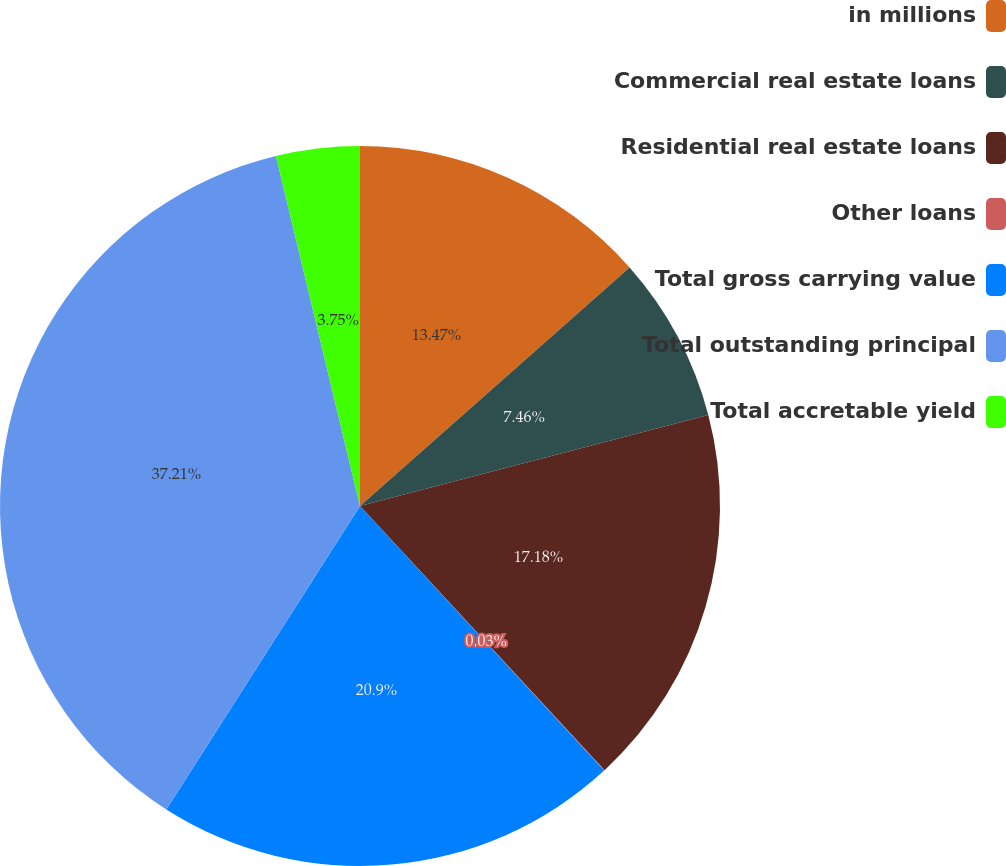Convert chart to OTSL. <chart><loc_0><loc_0><loc_500><loc_500><pie_chart><fcel>in millions<fcel>Commercial real estate loans<fcel>Residential real estate loans<fcel>Other loans<fcel>Total gross carrying value<fcel>Total outstanding principal<fcel>Total accretable yield<nl><fcel>13.47%<fcel>7.46%<fcel>17.18%<fcel>0.03%<fcel>20.9%<fcel>37.21%<fcel>3.75%<nl></chart> 